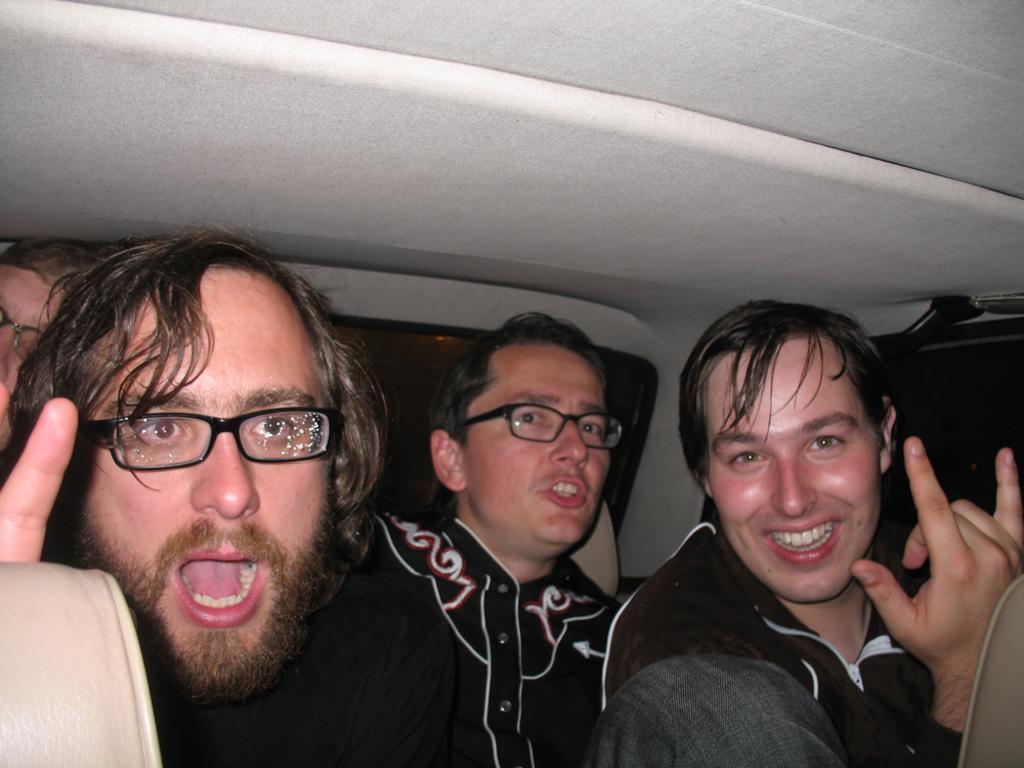Describe this image in one or two sentences. In this image there are group of people who are smiling and three of them are wearing spectacles, and it seems that they are sitting in a vehicle. 